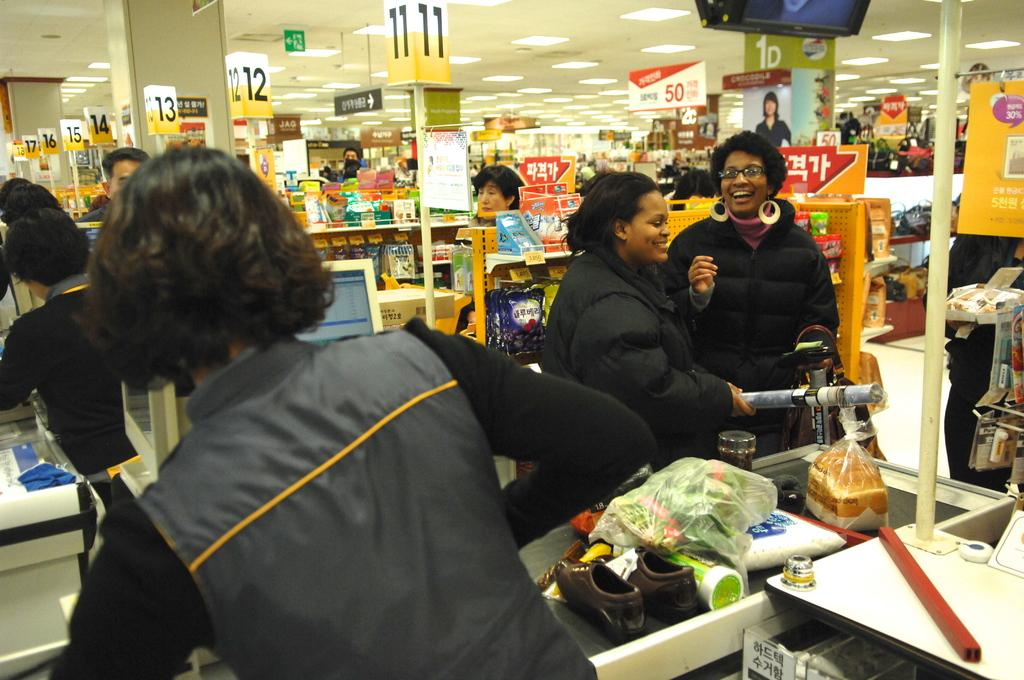Provide a one-sentence caption for the provided image. Two women in line near lane 11 are laughing together. 